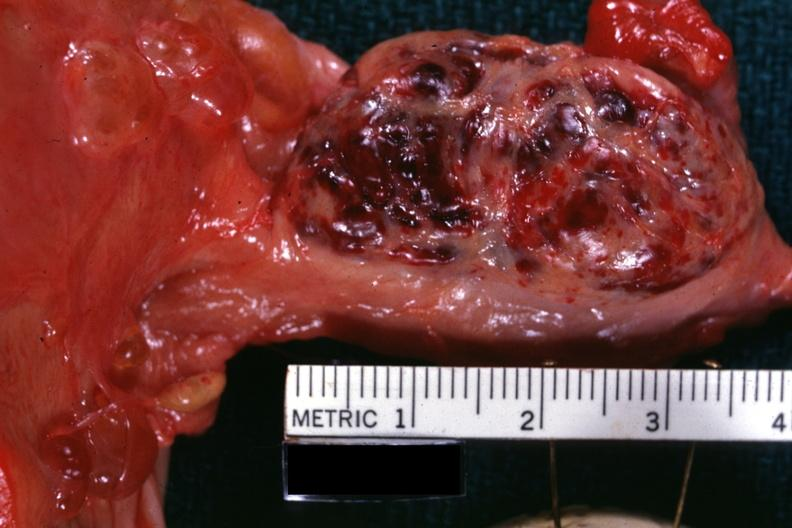what is this luteum from photo?
Answer the question using a single word or phrase. A corpus 